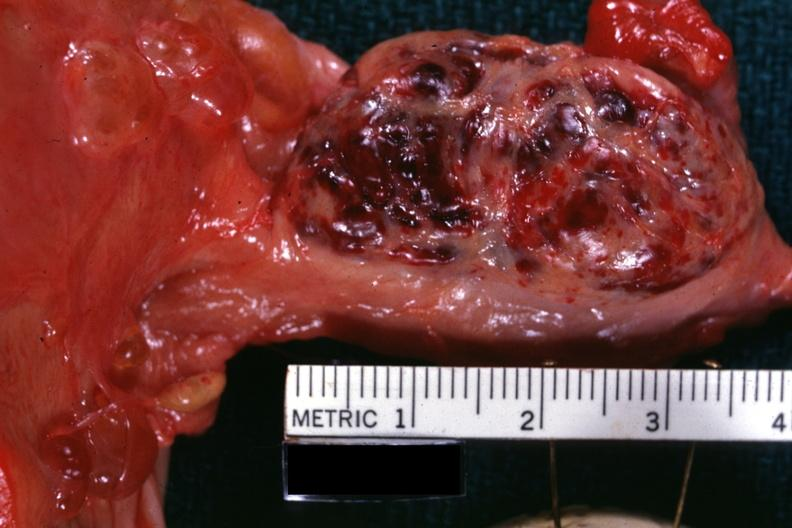what is this luteum from photo?
Answer the question using a single word or phrase. A corpus 